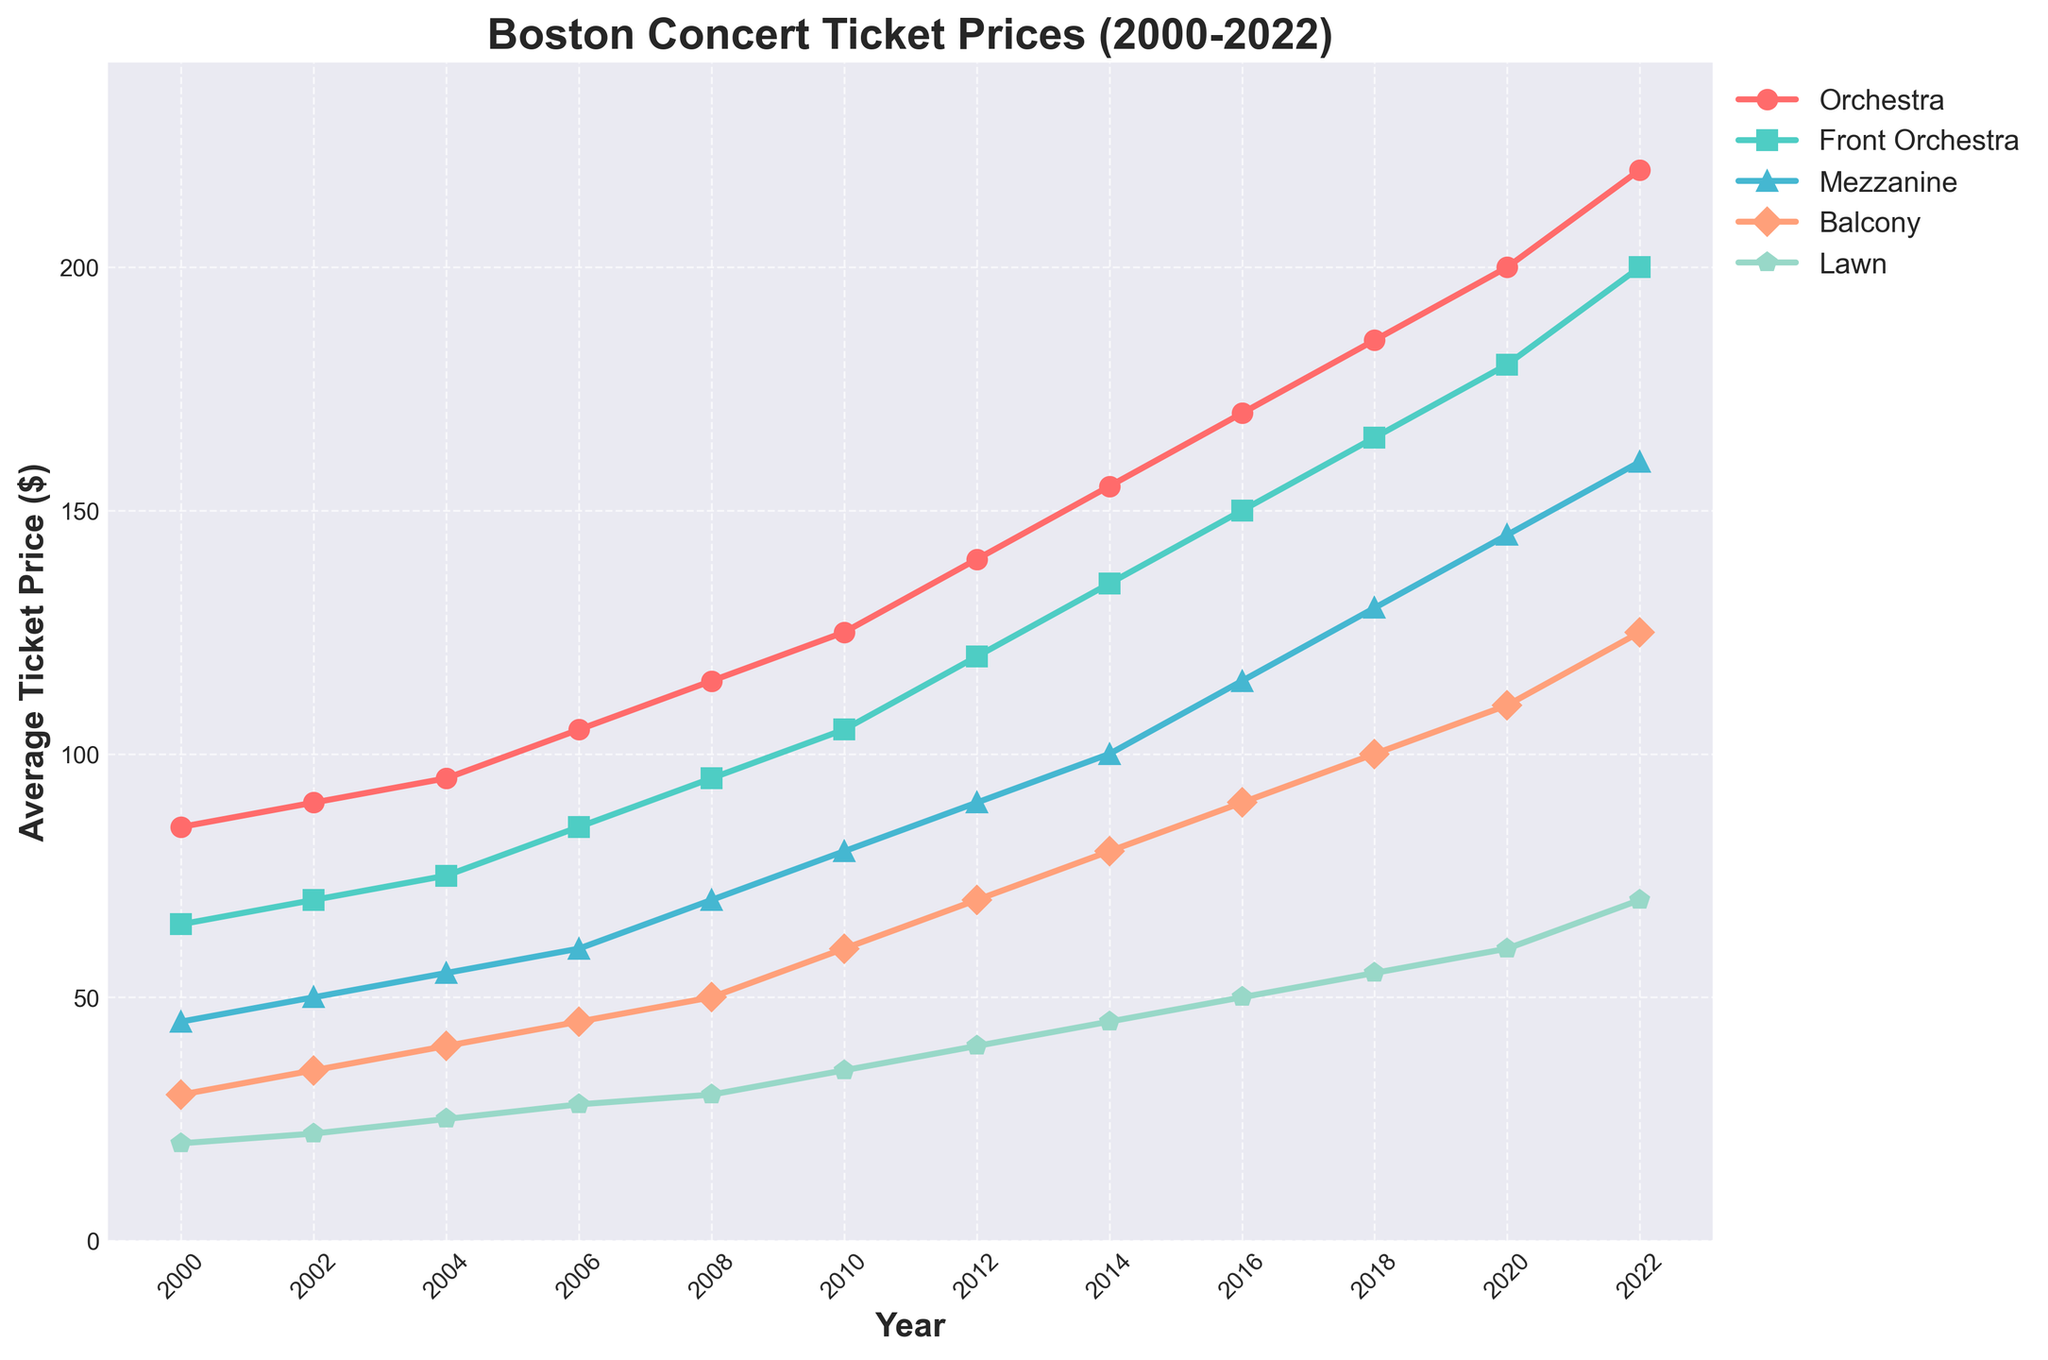What was the average ticket price for the Orchestra category in 2012 and 2016? Look at the Orchestra price in the year 2012 which is $140, and in 2016 which is $170. Average them: (140 + 170) / 2 = $155
Answer: $155 Which seating category showed the largest increase in average ticket price from 2000 to 2022? Calculate the difference in prices from 2000 to 2022 for each category: Orchestra (220-85=135), Front Orchestra (200-65=135), Mezzanine (160-45=115), Balcony (125-30=95), Lawn (70-20=50). The largest increase is 135.
Answer: Orchestra and Front Orchestra In which year did the Lawn category first reach an average ticket price of $50 or more? Following the Lawn prices, 2016 shows the average ticket price reaching $50 for the first time.
Answer: 2016 What was the difference in average ticket prices between the Orchestra and Balcony categories in 2022? The Orchestra price in 2022 is $220 and the Balcony price is $125. The difference is 220 - 125 = $95.
Answer: $95 Which category had the highest average ticket price in 2010, and what was it? In 2010, the categories have the following prices: Orchestra ($125), Front Orchestra ($105), Mezzanine ($80), Balcony ($60), Lawn ($35). Hence, the highest is Orchestra at $125.
Answer: Orchestra, $125 Between which two successive years did the Mezzanine category see the greatest increase in average ticket price? Check the price differences for the Mezzanine category between each successive year: 2002-2000 (50-45 = 5), 2004-2002 (55-50 = 5), 2006-2004 (60-55 = 5), 2008-2006 (70-60 = 10), 2010-2008 (80-70 = 10), 2012-2010 (90-80 = 10), 2014-2012 (100-90 = 10), 2016-2014 (115-100 = 15), 2018-2016 (130-115 = 15), 2020-2018 (145-130 = 15), 2022-2020 (160-145 = 15). The greatest increase is 15, occurring between 2014-2016, 2016-2018, 2018-2020, and 2020-2022.
Answer: 2014-2016, 2016-2018, 2018-2020, and 2020-2022 What color represents the Lawn category on the line chart? Look at the color used in the chart to represent the Lawn category, which is light green.
Answer: Light green What was the trend in average ticket prices for all seating categories from 2000 to 2022? All categories show an increasing trend in average ticket prices from 2000 to 2022.
Answer: Increasing 